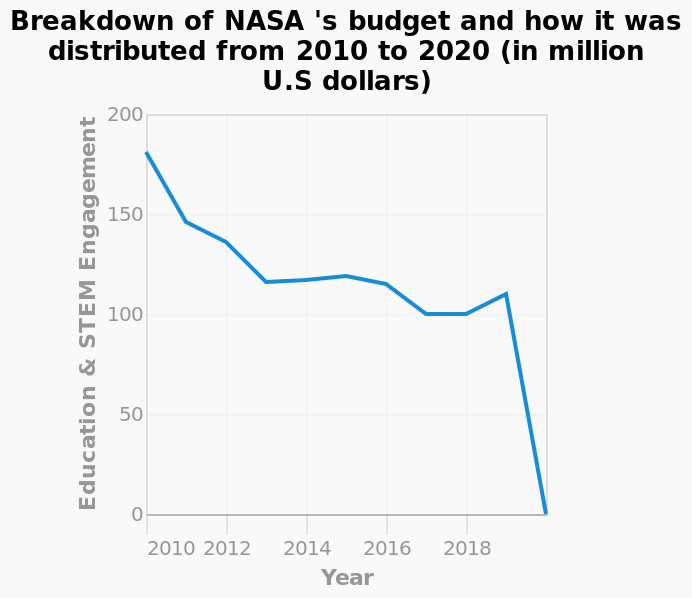<image>
How much was spent in 2019 on Education & STEM Engagement?  In ~2019, there was an extremely sharp decline from $110 million spent to $0. What does the y-axis of the line diagram represent?  The y-axis represents Education & STEM Engagement. What happened to the budget for Education & STEM Engagement between 2010 and 2018?  The budget for Education & STEM Engagement gradually decreased overall between 2010 and 2018. please summary the statistics and relations of the chart The budget for Education & STEM Engagement gradually decreased overall between 2010 and 2018. In ~2019 there was an extremely sharp decline from $110 million spent to $0. 